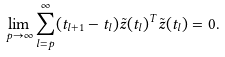<formula> <loc_0><loc_0><loc_500><loc_500>\lim _ { p \to \infty } \sum _ { l = p } ^ { \infty } ( t _ { l + 1 } - t _ { l } ) \tilde { z } ( t _ { l } ) ^ { T } \tilde { z } ( t _ { l } ) = 0 .</formula> 